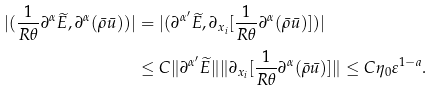Convert formula to latex. <formula><loc_0><loc_0><loc_500><loc_500>| ( \frac { 1 } { R \theta } \partial ^ { \alpha } \widetilde { E } , \partial ^ { \alpha } ( \bar { \rho } \bar { u } ) ) | & = | ( \partial ^ { \alpha ^ { \prime } } \widetilde { E } , \partial _ { x _ { i } } [ \frac { 1 } { R \theta } \partial ^ { \alpha } ( \bar { \rho } \bar { u } ) ] ) | \\ & \leq C \| \partial ^ { \alpha ^ { \prime } } \widetilde { E } \| \| \partial _ { x _ { i } } [ \frac { 1 } { R \theta } \partial ^ { \alpha } ( \bar { \rho } \bar { u } ) ] \| \leq C \eta _ { 0 } \varepsilon ^ { 1 - a } .</formula> 